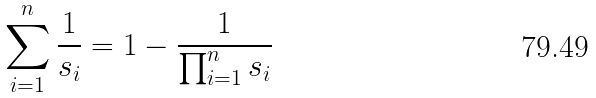Convert formula to latex. <formula><loc_0><loc_0><loc_500><loc_500>\sum _ { i = 1 } ^ { n } \frac { 1 } { s _ { i } } = 1 - \frac { 1 } { \prod _ { i = 1 } ^ { n } s _ { i } }</formula> 